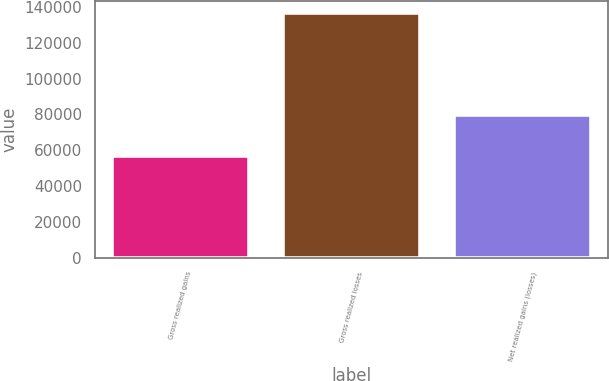Convert chart. <chart><loc_0><loc_0><loc_500><loc_500><bar_chart><fcel>Gross realized gains<fcel>Gross realized losses<fcel>Net realized gains (losses)<nl><fcel>56879<fcel>136296<fcel>79417<nl></chart> 